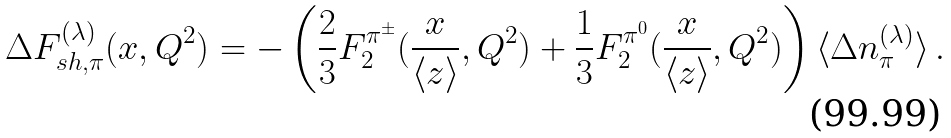<formula> <loc_0><loc_0><loc_500><loc_500>\Delta F _ { s h , \pi } ^ { ( \lambda ) } ( x , Q ^ { 2 } ) = - \left ( \frac { 2 } { 3 } F _ { 2 } ^ { \pi ^ { \pm } } ( \frac { x } { \langle z \rangle } , Q ^ { 2 } ) + \frac { 1 } { 3 } F _ { 2 } ^ { \pi ^ { 0 } } ( \frac { x } { \langle z \rangle } , Q ^ { 2 } ) \right ) \langle \Delta n ^ { ( \lambda ) } _ { \pi } \rangle \, .</formula> 